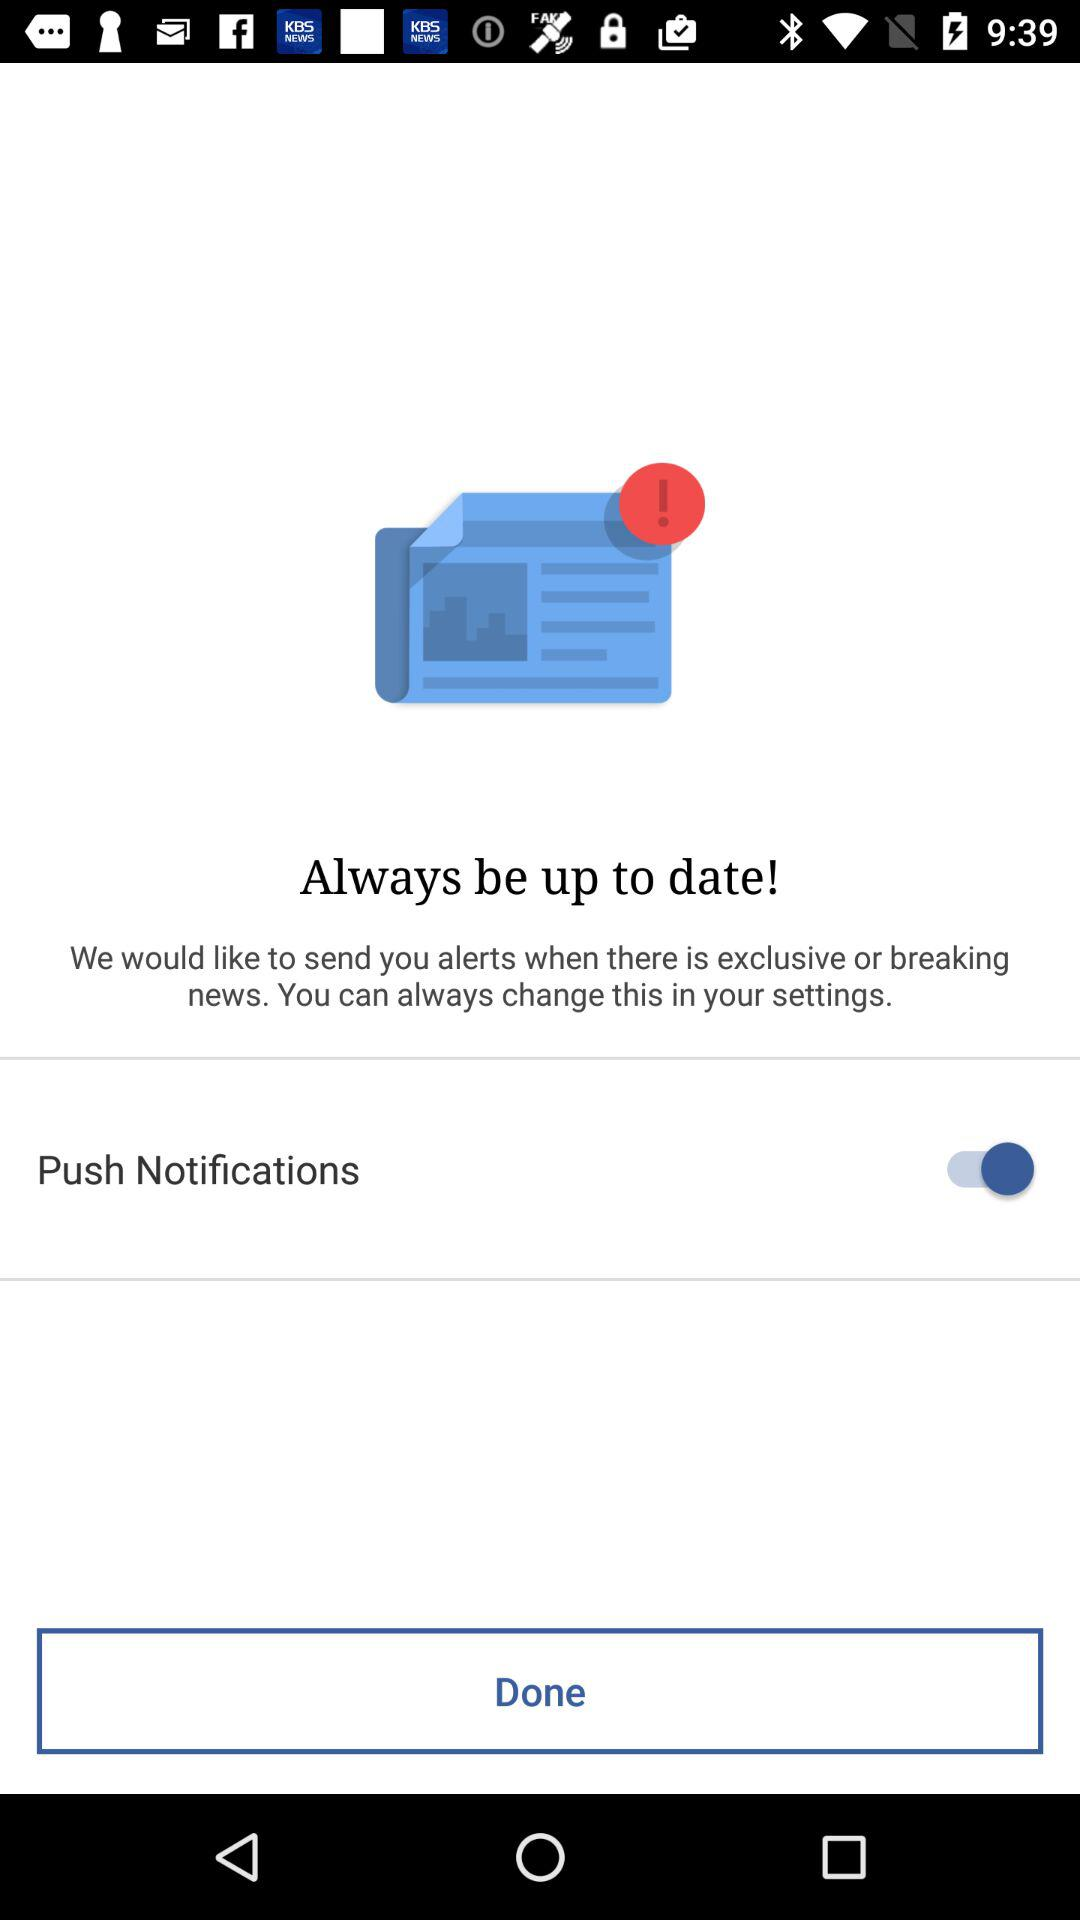Who is this application powered by?
When the provided information is insufficient, respond with <no answer>. <no answer> 